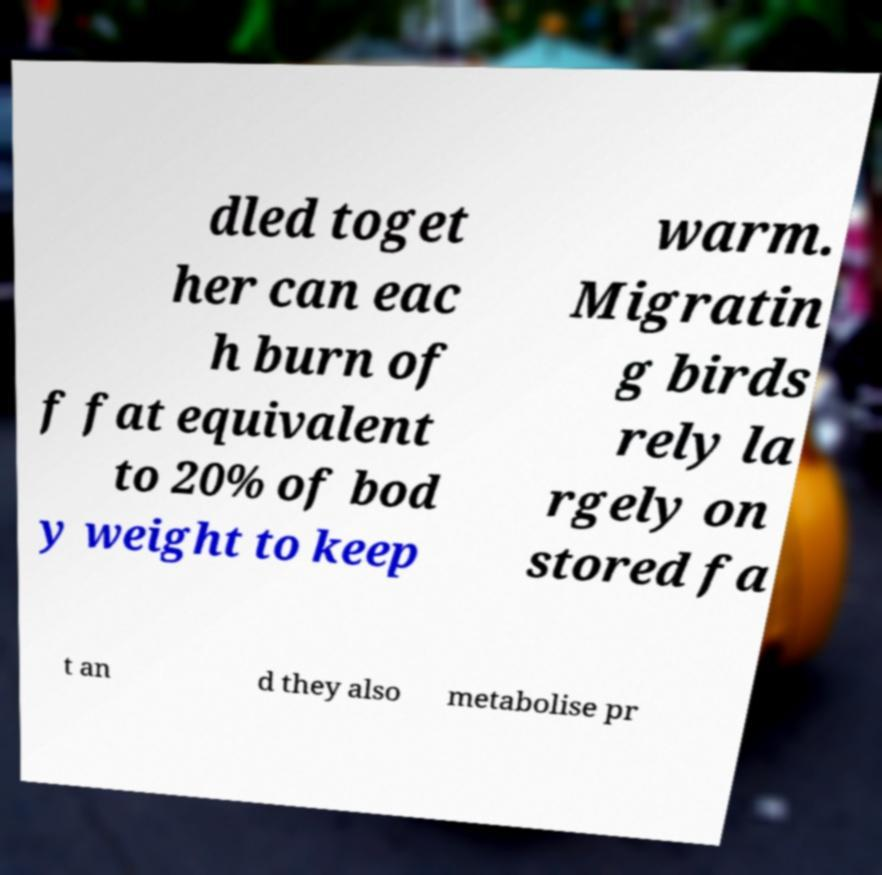Could you extract and type out the text from this image? dled toget her can eac h burn of f fat equivalent to 20% of bod y weight to keep warm. Migratin g birds rely la rgely on stored fa t an d they also metabolise pr 